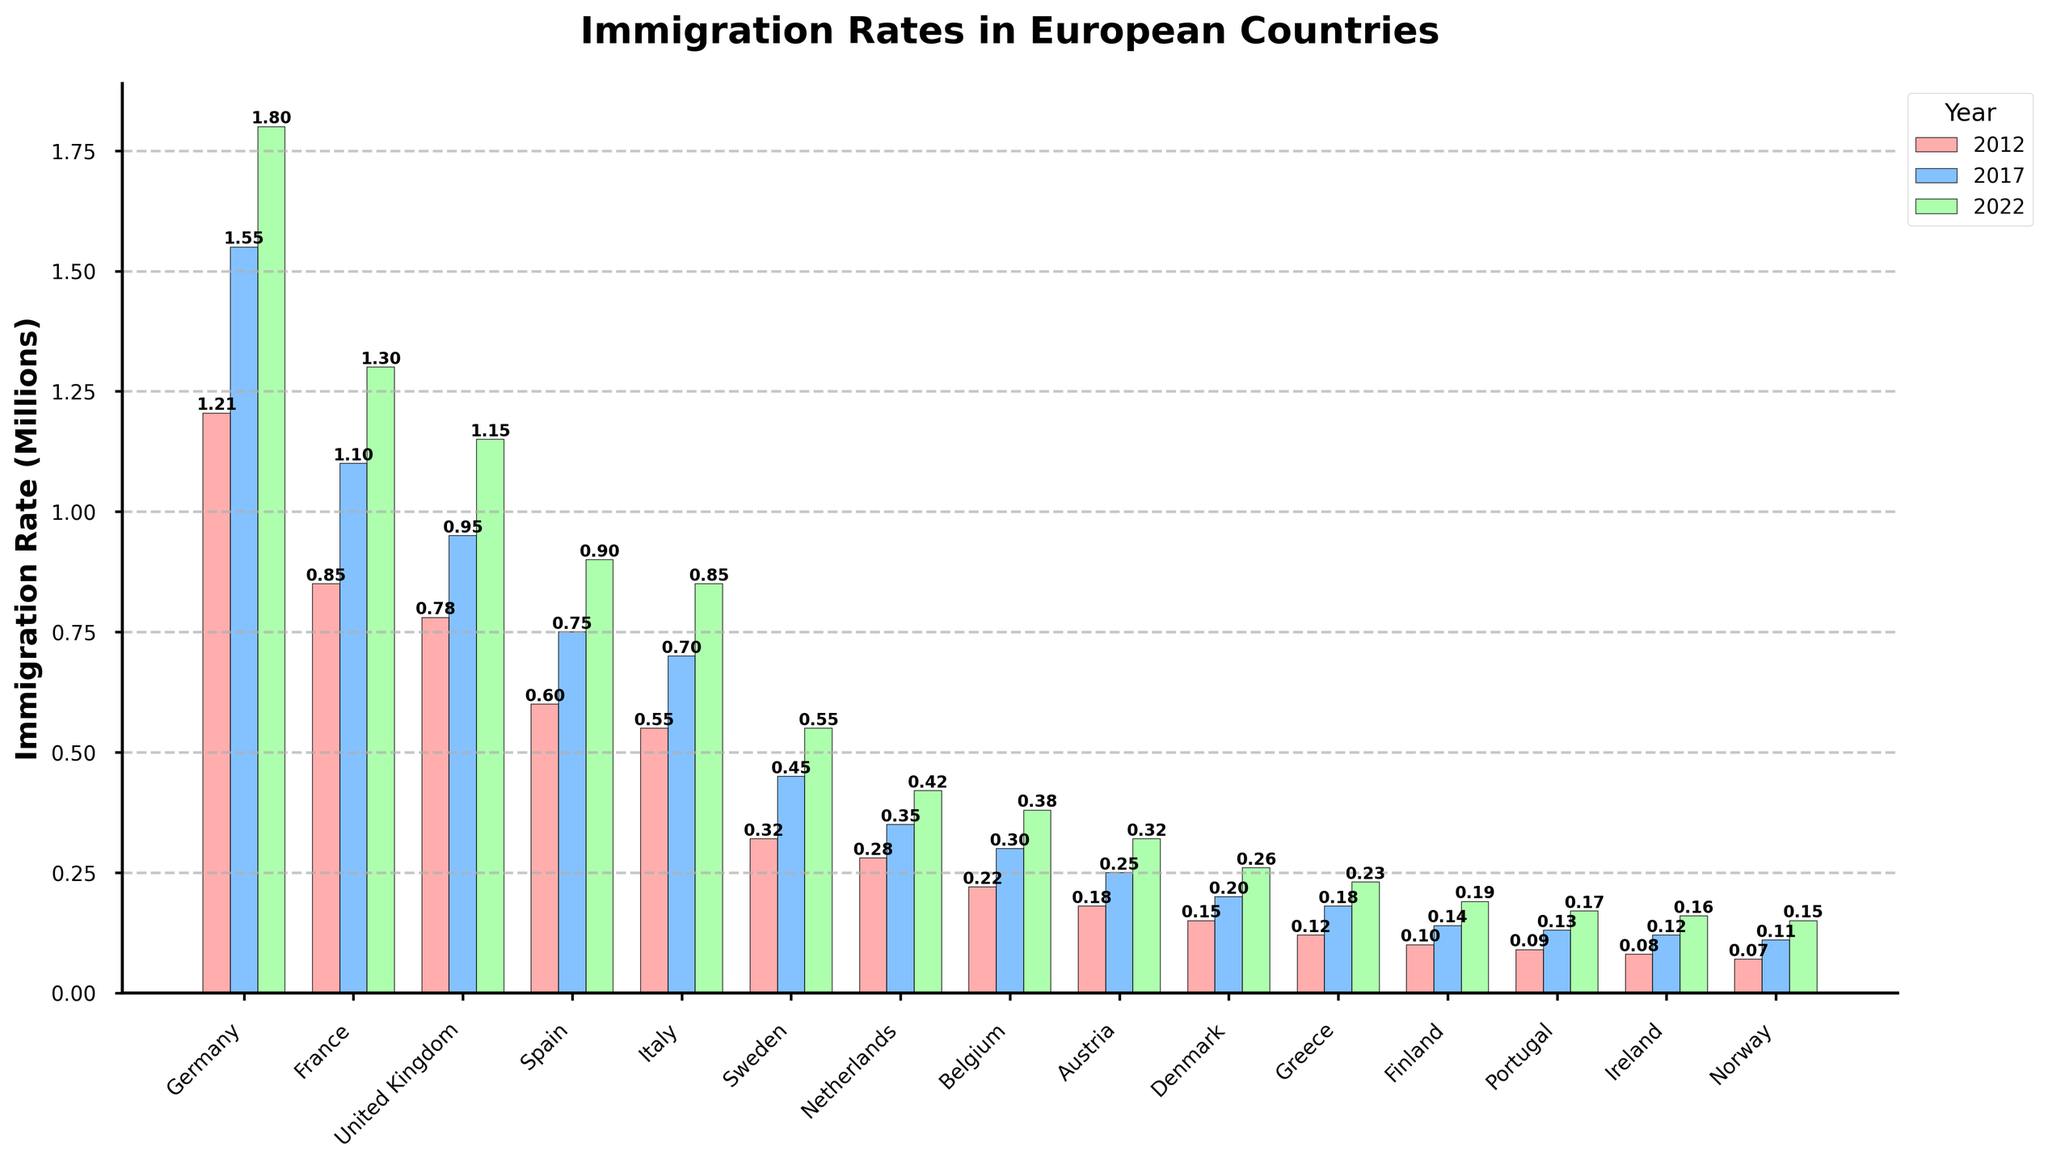What is the total immigration rate for Germany across 2012, 2017, and 2022? Sum the immigration rates for Germany for the three years: 1.205 million (2012) + 1.55 million (2017) + 1.8 million (2022). The total is 1.205 + 1.55 + 1.8 = 4.555 million.
Answer: 4.555 million Which country had the highest immigration rate in 2022? Observe the height of the bars for 2022 across all countries. Germany has the tallest bar, indicating the highest rate.
Answer: Germany What is the average immigration rate of Sweden over the three years shown? Sum the immigration rates for Sweden for 2012, 2017, and 2022 and divide by 3: (0.32 + 0.45 + 0.55) / 3. The sum is 1.32, and the average is 1.32 / 3 = 0.44 million.
Answer: 0.44 million Which countries had a greater immigration rate in 2017 than in 2012? Compare the heights of the 2017 and 2012 bars for each country. Germany, France, United Kingdom, Spain, Italy, Sweden, Netherlands, Belgium, Austria, Denmark, Greece, Finland, Portugal, Ireland, and Norway all show taller bars in 2017 compared to 2012.
Answer: All countries What is the difference in the immigration rates between France and Italy in 2022? Subtract Italy's immigration rate from France's for 2022: 1.3 million (France) - 0.85 million (Italy) = 0.45 million.
Answer: 0.45 million How did the immigration rate of Denmark change from 2012 to 2022? Compare the heights of the 2012 and 2022 bars. In 2012 the rate was 0.15 million and in 2022 it was 0.26 million. The change is 0.26 - 0.15 = 0.11 million.
Answer: Increased by 0.11 million Which country had the smallest immigration rate in 2012, and what was the rate? Look for the smallest bar in 2012. Norway has the smallest bar with an immigration rate of 0.07 million.
Answer: Norway, 0.07 million What is the combined immigration rate for Germany and the United Kingdom in 2022? Add the immigration rates for Germany and the United Kingdom in 2022: 1.8 million (Germany) + 1.15 million (United Kingdom) = 2.95 million.
Answer: 2.95 million What visually noticeable pattern can you observe in the immigration trends for most countries? Many countries show a consistent increase in immigration rates over the years, visible through the progressively higher bars from 2012 to 2017 to 2022.
Answer: Increasing trend 